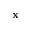<formula> <loc_0><loc_0><loc_500><loc_500>{ x }</formula> 